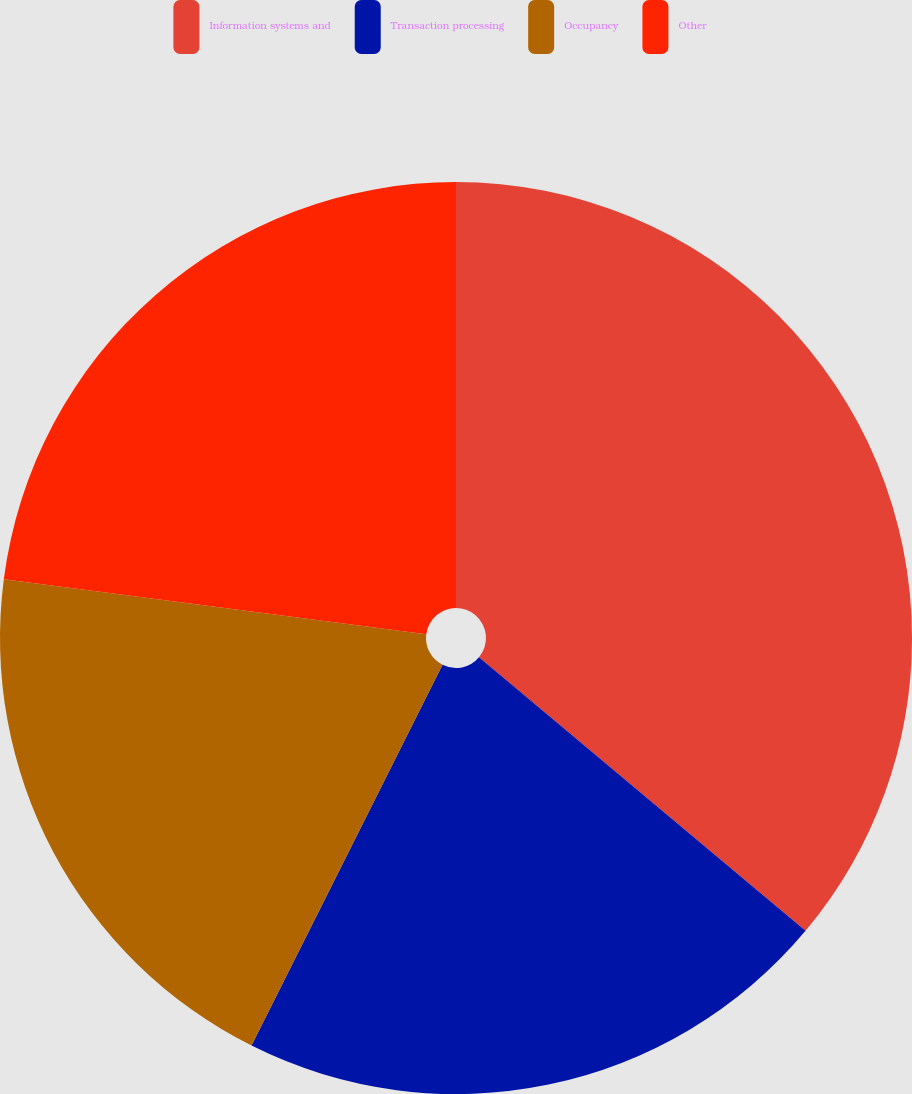<chart> <loc_0><loc_0><loc_500><loc_500><pie_chart><fcel>Information systems and<fcel>Transaction processing<fcel>Occupancy<fcel>Other<nl><fcel>36.1%<fcel>21.3%<fcel>19.66%<fcel>22.94%<nl></chart> 